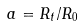Convert formula to latex. <formula><loc_0><loc_0><loc_500><loc_500>a = R _ { t } / R _ { 0 }</formula> 